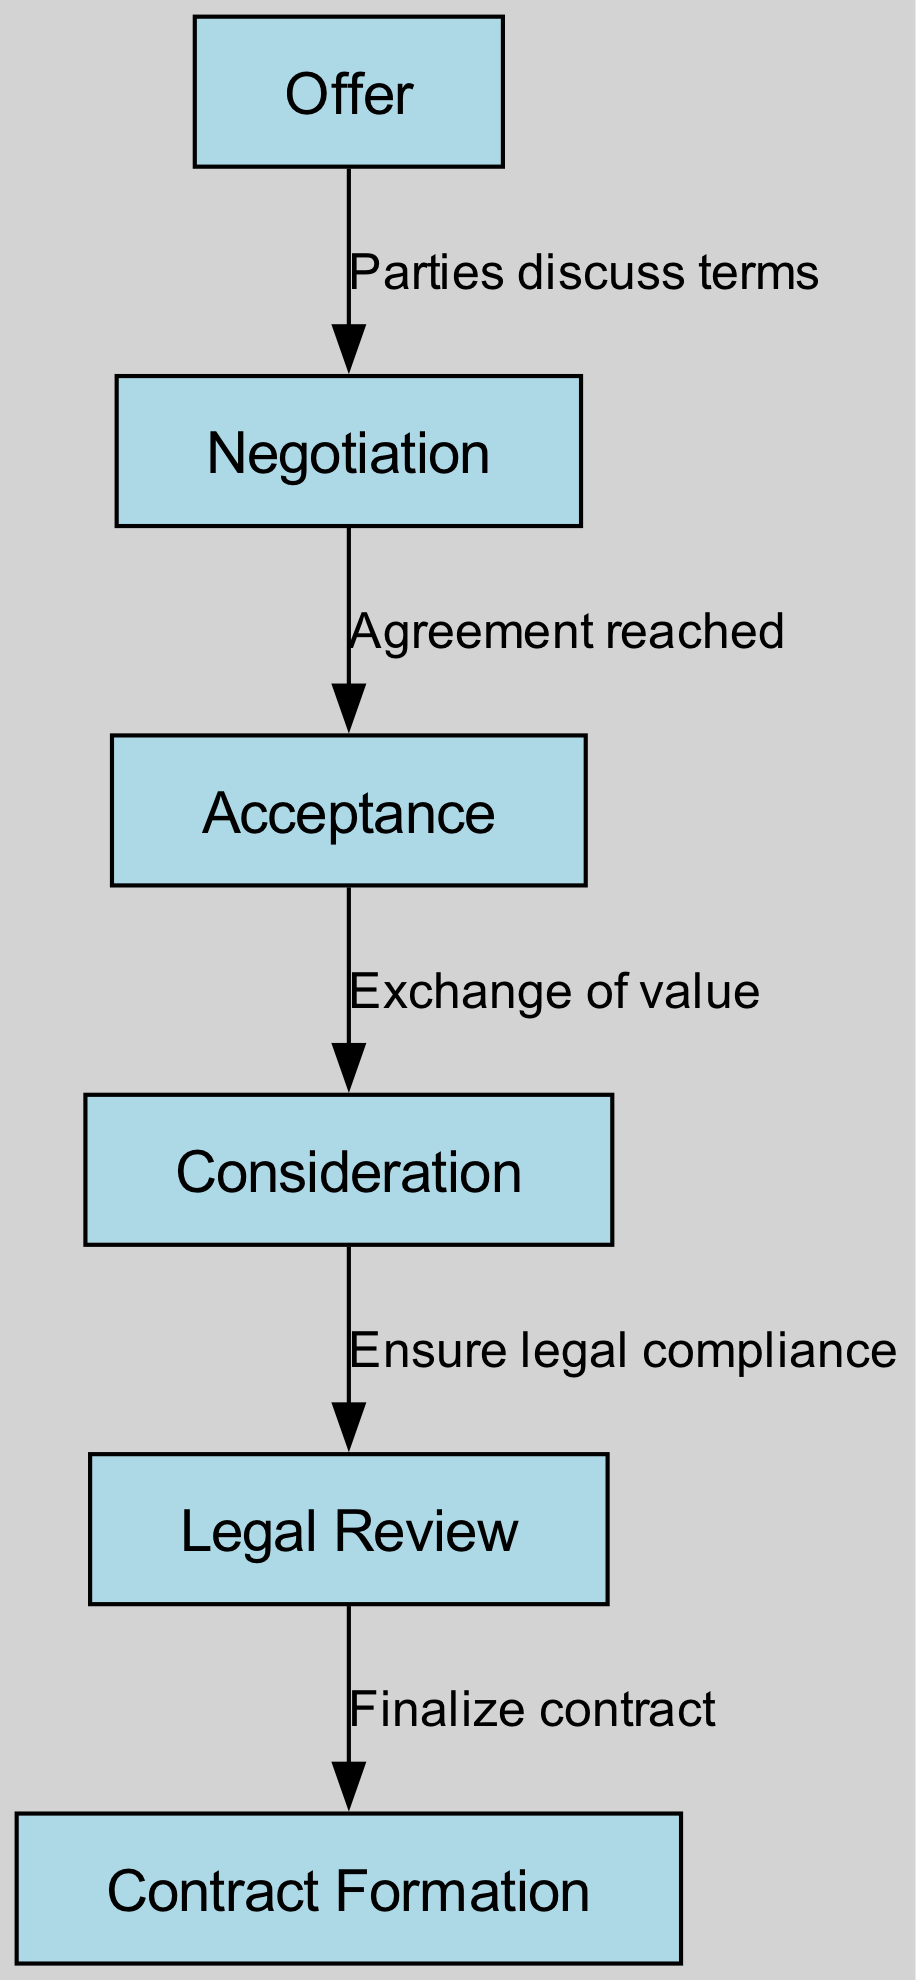What is the first stage of contract formation? The diagram shows that the first node, labeled “Offer,” is identified as the starting point in the contract formation process.
Answer: Offer How many nodes are present in the diagram? By counting the nodes listed in the data, there are a total of six unique nodes representing various stages of contract formation.
Answer: 6 What label connects "Acceptance" to "Consideration"? The edge connecting “Acceptance” to “Consideration” is labeled "Exchange of value," indicating the flow of the process.
Answer: Exchange of value What stage follows "Negotiation"? The diagram indicates that the stage following “Negotiation” is “Acceptance,” which occurs once an agreement has been reached.
Answer: Acceptance What is the final stage in the contract formation process? According to the diagram, the last phase in the diagram is “Contract Formation,” which culminates the entire process.
Answer: Contract Formation Which stages ensure legal compliance? The diagram illustrates that legal compliance is ensured during the “Legal Review” stage, which follows “Consideration.”
Answer: Legal Review What is the relationship between "Consideration" and "Legal Review"? The edge between “Consideration” and “Legal Review” is labeled "Ensure legal compliance," highlighting a direct relationship between these stages regarding legal aspects.
Answer: Ensure legal compliance How many edges are in the diagram? By counting each connection between nodes, there are five edges that represent the transitions from one stage to another in contract formation.
Answer: 5 What happens after "Acceptance"? Following the “Acceptance” stage, the next action is the "Exchange of value," indicating a crucial step before moving to the consideration phase.
Answer: Exchange of value 